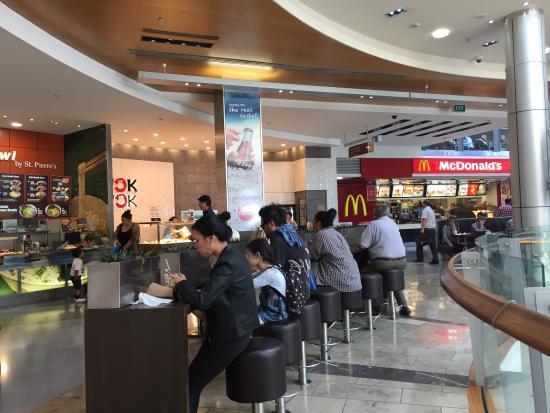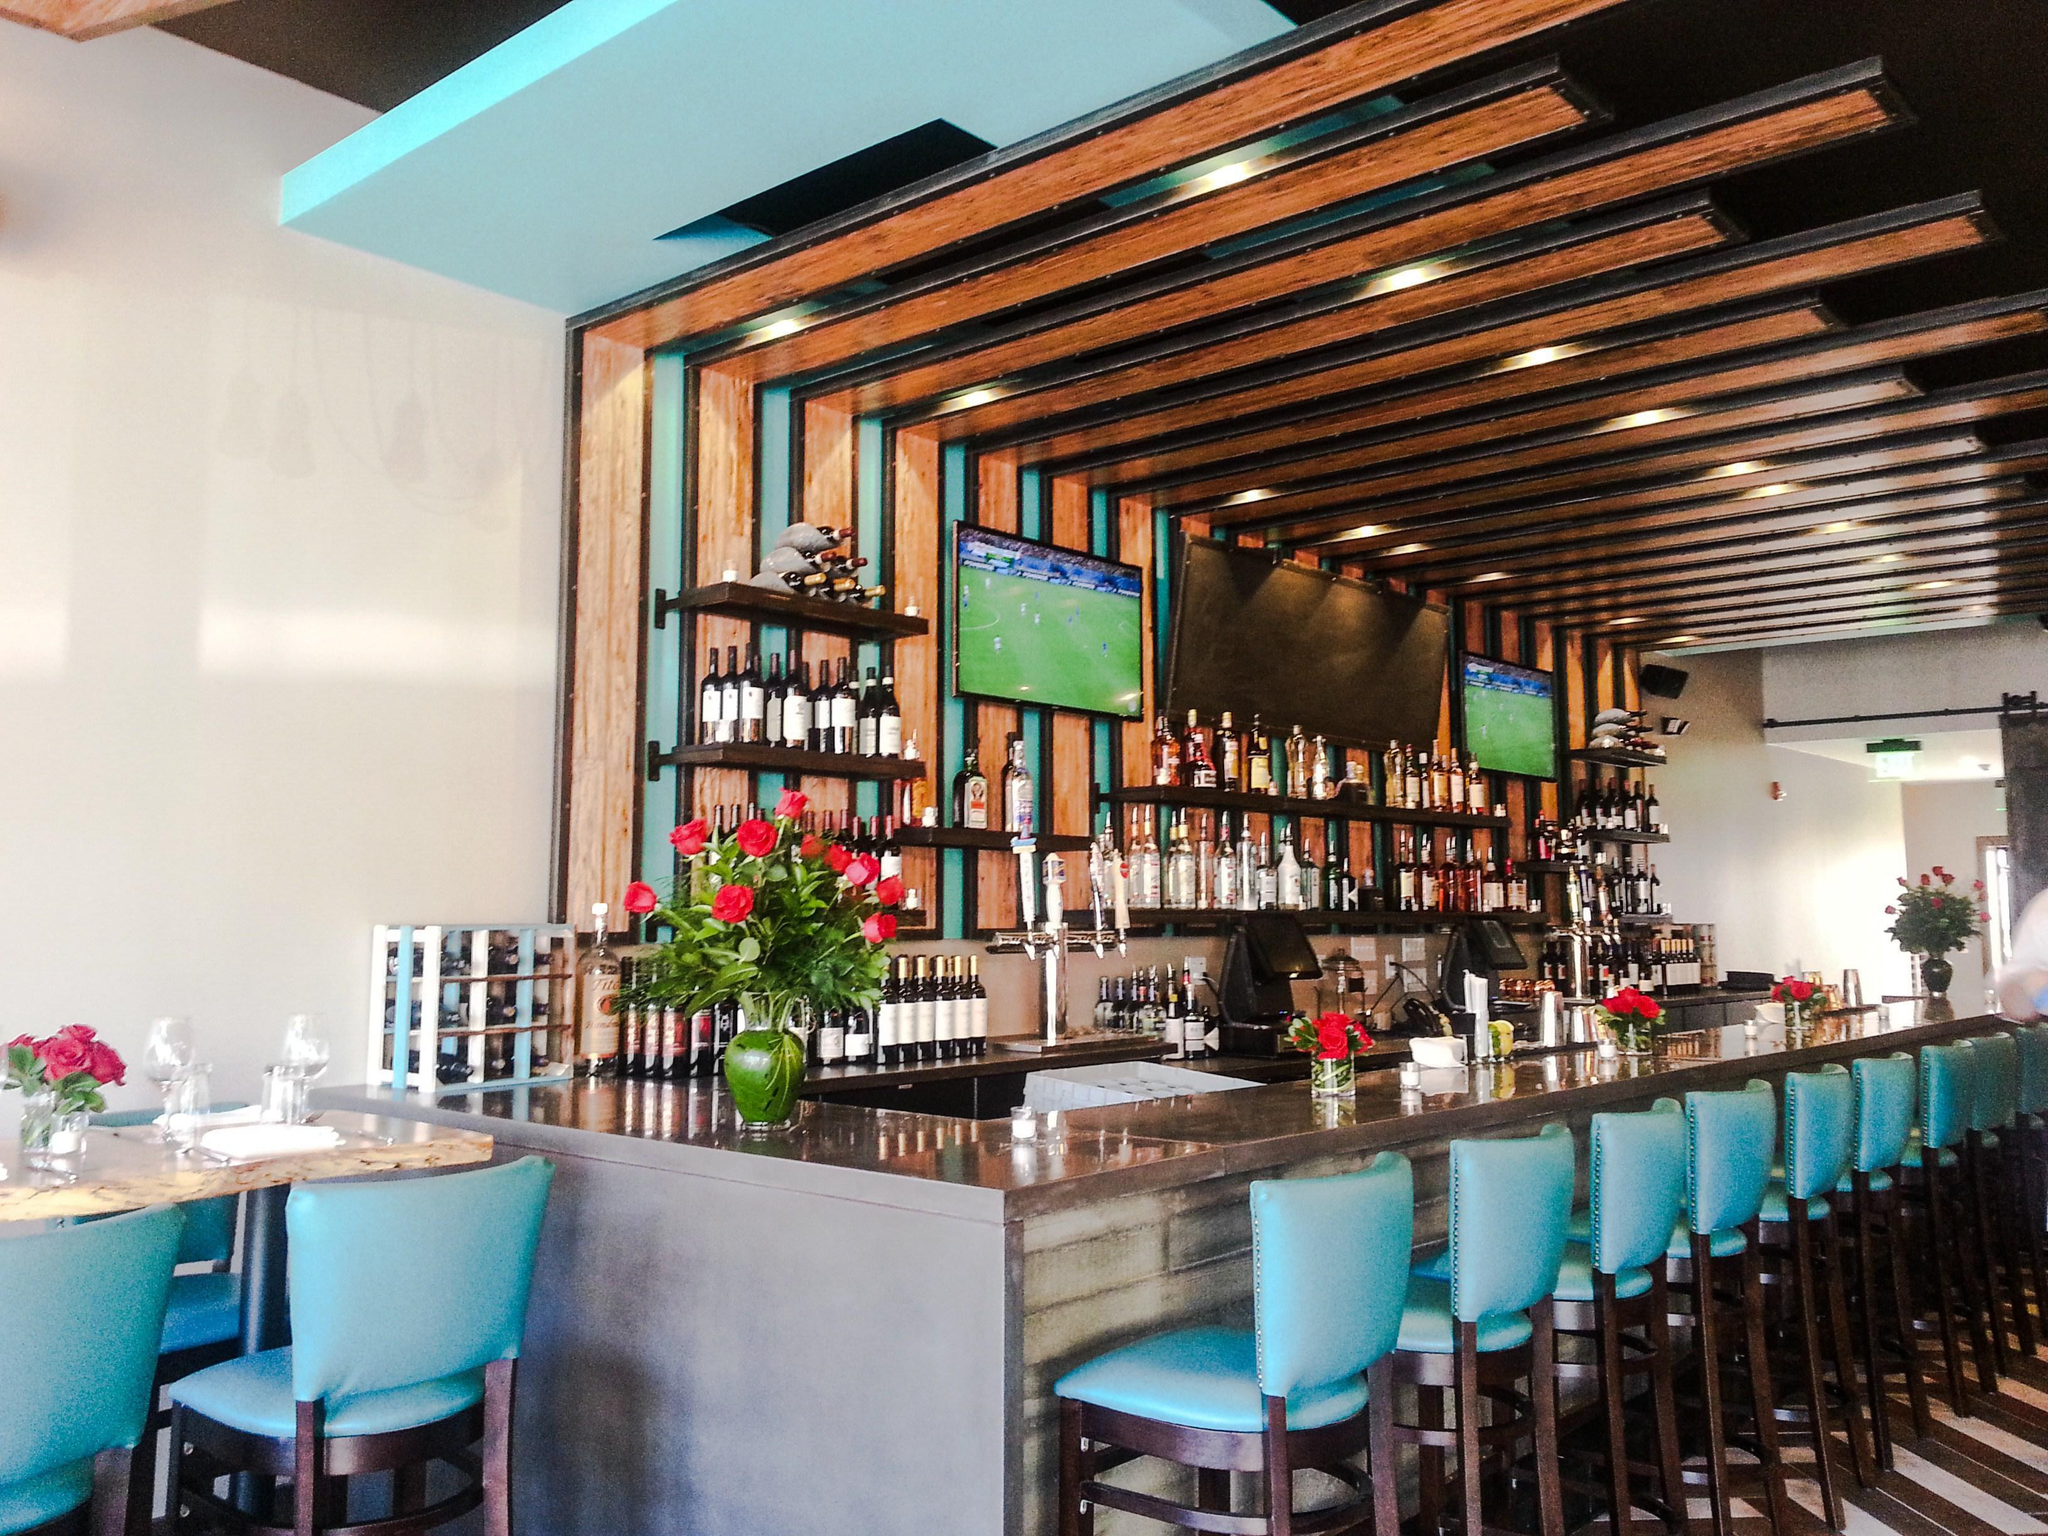The first image is the image on the left, the second image is the image on the right. Considering the images on both sides, is "One of the restaurants has several customers sitting in chairs." valid? Answer yes or no. Yes. The first image is the image on the left, the second image is the image on the right. For the images shown, is this caption "There are two cafes with internal views." true? Answer yes or no. Yes. 